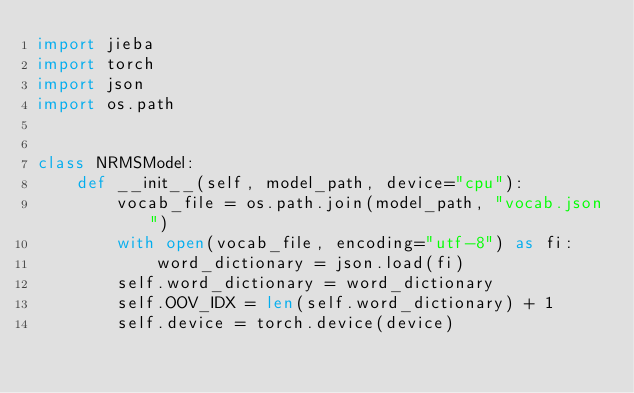Convert code to text. <code><loc_0><loc_0><loc_500><loc_500><_Python_>import jieba
import torch
import json
import os.path


class NRMSModel:
    def __init__(self, model_path, device="cpu"):
        vocab_file = os.path.join(model_path, "vocab.json")
        with open(vocab_file, encoding="utf-8") as fi:
            word_dictionary = json.load(fi)
        self.word_dictionary = word_dictionary
        self.OOV_IDX = len(self.word_dictionary) + 1
        self.device = torch.device(device)</code> 